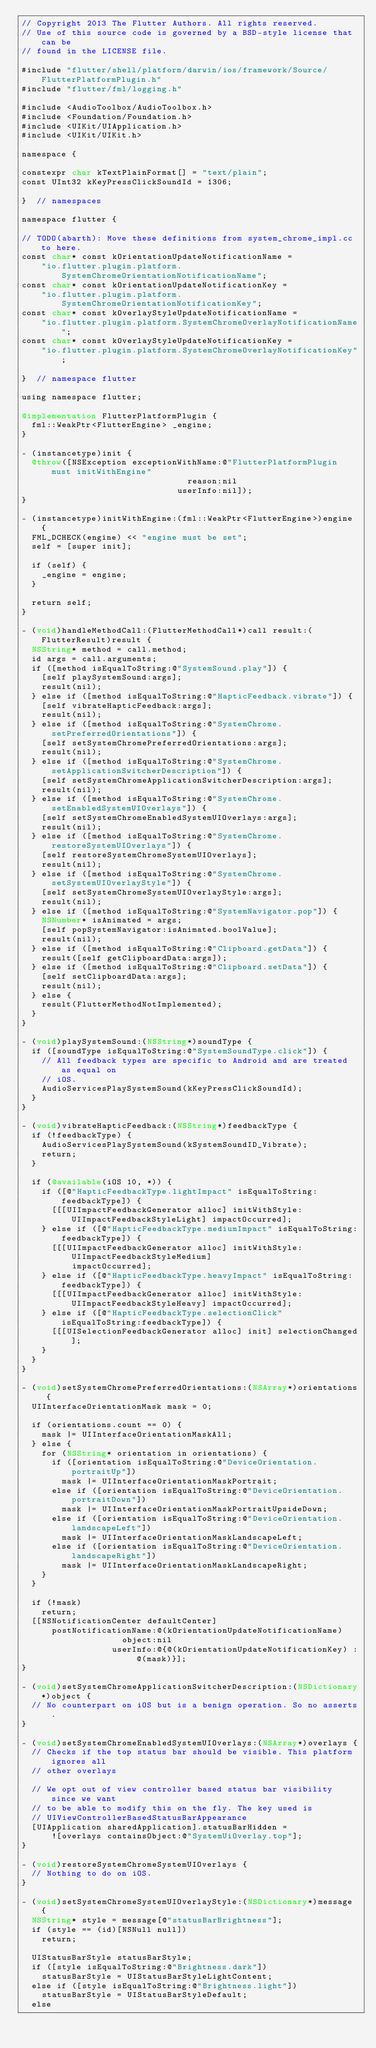<code> <loc_0><loc_0><loc_500><loc_500><_ObjectiveC_>// Copyright 2013 The Flutter Authors. All rights reserved.
// Use of this source code is governed by a BSD-style license that can be
// found in the LICENSE file.

#include "flutter/shell/platform/darwin/ios/framework/Source/FlutterPlatformPlugin.h"
#include "flutter/fml/logging.h"

#include <AudioToolbox/AudioToolbox.h>
#include <Foundation/Foundation.h>
#include <UIKit/UIApplication.h>
#include <UIKit/UIKit.h>

namespace {

constexpr char kTextPlainFormat[] = "text/plain";
const UInt32 kKeyPressClickSoundId = 1306;

}  // namespaces

namespace flutter {

// TODO(abarth): Move these definitions from system_chrome_impl.cc to here.
const char* const kOrientationUpdateNotificationName =
    "io.flutter.plugin.platform.SystemChromeOrientationNotificationName";
const char* const kOrientationUpdateNotificationKey =
    "io.flutter.plugin.platform.SystemChromeOrientationNotificationKey";
const char* const kOverlayStyleUpdateNotificationName =
    "io.flutter.plugin.platform.SystemChromeOverlayNotificationName";
const char* const kOverlayStyleUpdateNotificationKey =
    "io.flutter.plugin.platform.SystemChromeOverlayNotificationKey";

}  // namespace flutter

using namespace flutter;

@implementation FlutterPlatformPlugin {
  fml::WeakPtr<FlutterEngine> _engine;
}

- (instancetype)init {
  @throw([NSException exceptionWithName:@"FlutterPlatformPlugin must initWithEngine"
                                 reason:nil
                               userInfo:nil]);
}

- (instancetype)initWithEngine:(fml::WeakPtr<FlutterEngine>)engine {
  FML_DCHECK(engine) << "engine must be set";
  self = [super init];

  if (self) {
    _engine = engine;
  }

  return self;
}

- (void)handleMethodCall:(FlutterMethodCall*)call result:(FlutterResult)result {
  NSString* method = call.method;
  id args = call.arguments;
  if ([method isEqualToString:@"SystemSound.play"]) {
    [self playSystemSound:args];
    result(nil);
  } else if ([method isEqualToString:@"HapticFeedback.vibrate"]) {
    [self vibrateHapticFeedback:args];
    result(nil);
  } else if ([method isEqualToString:@"SystemChrome.setPreferredOrientations"]) {
    [self setSystemChromePreferredOrientations:args];
    result(nil);
  } else if ([method isEqualToString:@"SystemChrome.setApplicationSwitcherDescription"]) {
    [self setSystemChromeApplicationSwitcherDescription:args];
    result(nil);
  } else if ([method isEqualToString:@"SystemChrome.setEnabledSystemUIOverlays"]) {
    [self setSystemChromeEnabledSystemUIOverlays:args];
    result(nil);
  } else if ([method isEqualToString:@"SystemChrome.restoreSystemUIOverlays"]) {
    [self restoreSystemChromeSystemUIOverlays];
    result(nil);
  } else if ([method isEqualToString:@"SystemChrome.setSystemUIOverlayStyle"]) {
    [self setSystemChromeSystemUIOverlayStyle:args];
    result(nil);
  } else if ([method isEqualToString:@"SystemNavigator.pop"]) {
    NSNumber* isAnimated = args;
    [self popSystemNavigator:isAnimated.boolValue];
    result(nil);
  } else if ([method isEqualToString:@"Clipboard.getData"]) {
    result([self getClipboardData:args]);
  } else if ([method isEqualToString:@"Clipboard.setData"]) {
    [self setClipboardData:args];
    result(nil);
  } else {
    result(FlutterMethodNotImplemented);
  }
}

- (void)playSystemSound:(NSString*)soundType {
  if ([soundType isEqualToString:@"SystemSoundType.click"]) {
    // All feedback types are specific to Android and are treated as equal on
    // iOS.
    AudioServicesPlaySystemSound(kKeyPressClickSoundId);
  }
}

- (void)vibrateHapticFeedback:(NSString*)feedbackType {
  if (!feedbackType) {
    AudioServicesPlaySystemSound(kSystemSoundID_Vibrate);
    return;
  }

  if (@available(iOS 10, *)) {
    if ([@"HapticFeedbackType.lightImpact" isEqualToString:feedbackType]) {
      [[[UIImpactFeedbackGenerator alloc] initWithStyle:UIImpactFeedbackStyleLight] impactOccurred];
    } else if ([@"HapticFeedbackType.mediumImpact" isEqualToString:feedbackType]) {
      [[[UIImpactFeedbackGenerator alloc] initWithStyle:UIImpactFeedbackStyleMedium]
          impactOccurred];
    } else if ([@"HapticFeedbackType.heavyImpact" isEqualToString:feedbackType]) {
      [[[UIImpactFeedbackGenerator alloc] initWithStyle:UIImpactFeedbackStyleHeavy] impactOccurred];
    } else if ([@"HapticFeedbackType.selectionClick" isEqualToString:feedbackType]) {
      [[[UISelectionFeedbackGenerator alloc] init] selectionChanged];
    }
  }
}

- (void)setSystemChromePreferredOrientations:(NSArray*)orientations {
  UIInterfaceOrientationMask mask = 0;

  if (orientations.count == 0) {
    mask |= UIInterfaceOrientationMaskAll;
  } else {
    for (NSString* orientation in orientations) {
      if ([orientation isEqualToString:@"DeviceOrientation.portraitUp"])
        mask |= UIInterfaceOrientationMaskPortrait;
      else if ([orientation isEqualToString:@"DeviceOrientation.portraitDown"])
        mask |= UIInterfaceOrientationMaskPortraitUpsideDown;
      else if ([orientation isEqualToString:@"DeviceOrientation.landscapeLeft"])
        mask |= UIInterfaceOrientationMaskLandscapeLeft;
      else if ([orientation isEqualToString:@"DeviceOrientation.landscapeRight"])
        mask |= UIInterfaceOrientationMaskLandscapeRight;
    }
  }

  if (!mask)
    return;
  [[NSNotificationCenter defaultCenter]
      postNotificationName:@(kOrientationUpdateNotificationName)
                    object:nil
                  userInfo:@{@(kOrientationUpdateNotificationKey) : @(mask)}];
}

- (void)setSystemChromeApplicationSwitcherDescription:(NSDictionary*)object {
  // No counterpart on iOS but is a benign operation. So no asserts.
}

- (void)setSystemChromeEnabledSystemUIOverlays:(NSArray*)overlays {
  // Checks if the top status bar should be visible. This platform ignores all
  // other overlays

  // We opt out of view controller based status bar visibility since we want
  // to be able to modify this on the fly. The key used is
  // UIViewControllerBasedStatusBarAppearance
  [UIApplication sharedApplication].statusBarHidden =
      ![overlays containsObject:@"SystemUiOverlay.top"];
}

- (void)restoreSystemChromeSystemUIOverlays {
  // Nothing to do on iOS.
}

- (void)setSystemChromeSystemUIOverlayStyle:(NSDictionary*)message {
  NSString* style = message[@"statusBarBrightness"];
  if (style == (id)[NSNull null])
    return;

  UIStatusBarStyle statusBarStyle;
  if ([style isEqualToString:@"Brightness.dark"])
    statusBarStyle = UIStatusBarStyleLightContent;
  else if ([style isEqualToString:@"Brightness.light"])
    statusBarStyle = UIStatusBarStyleDefault;
  else</code> 